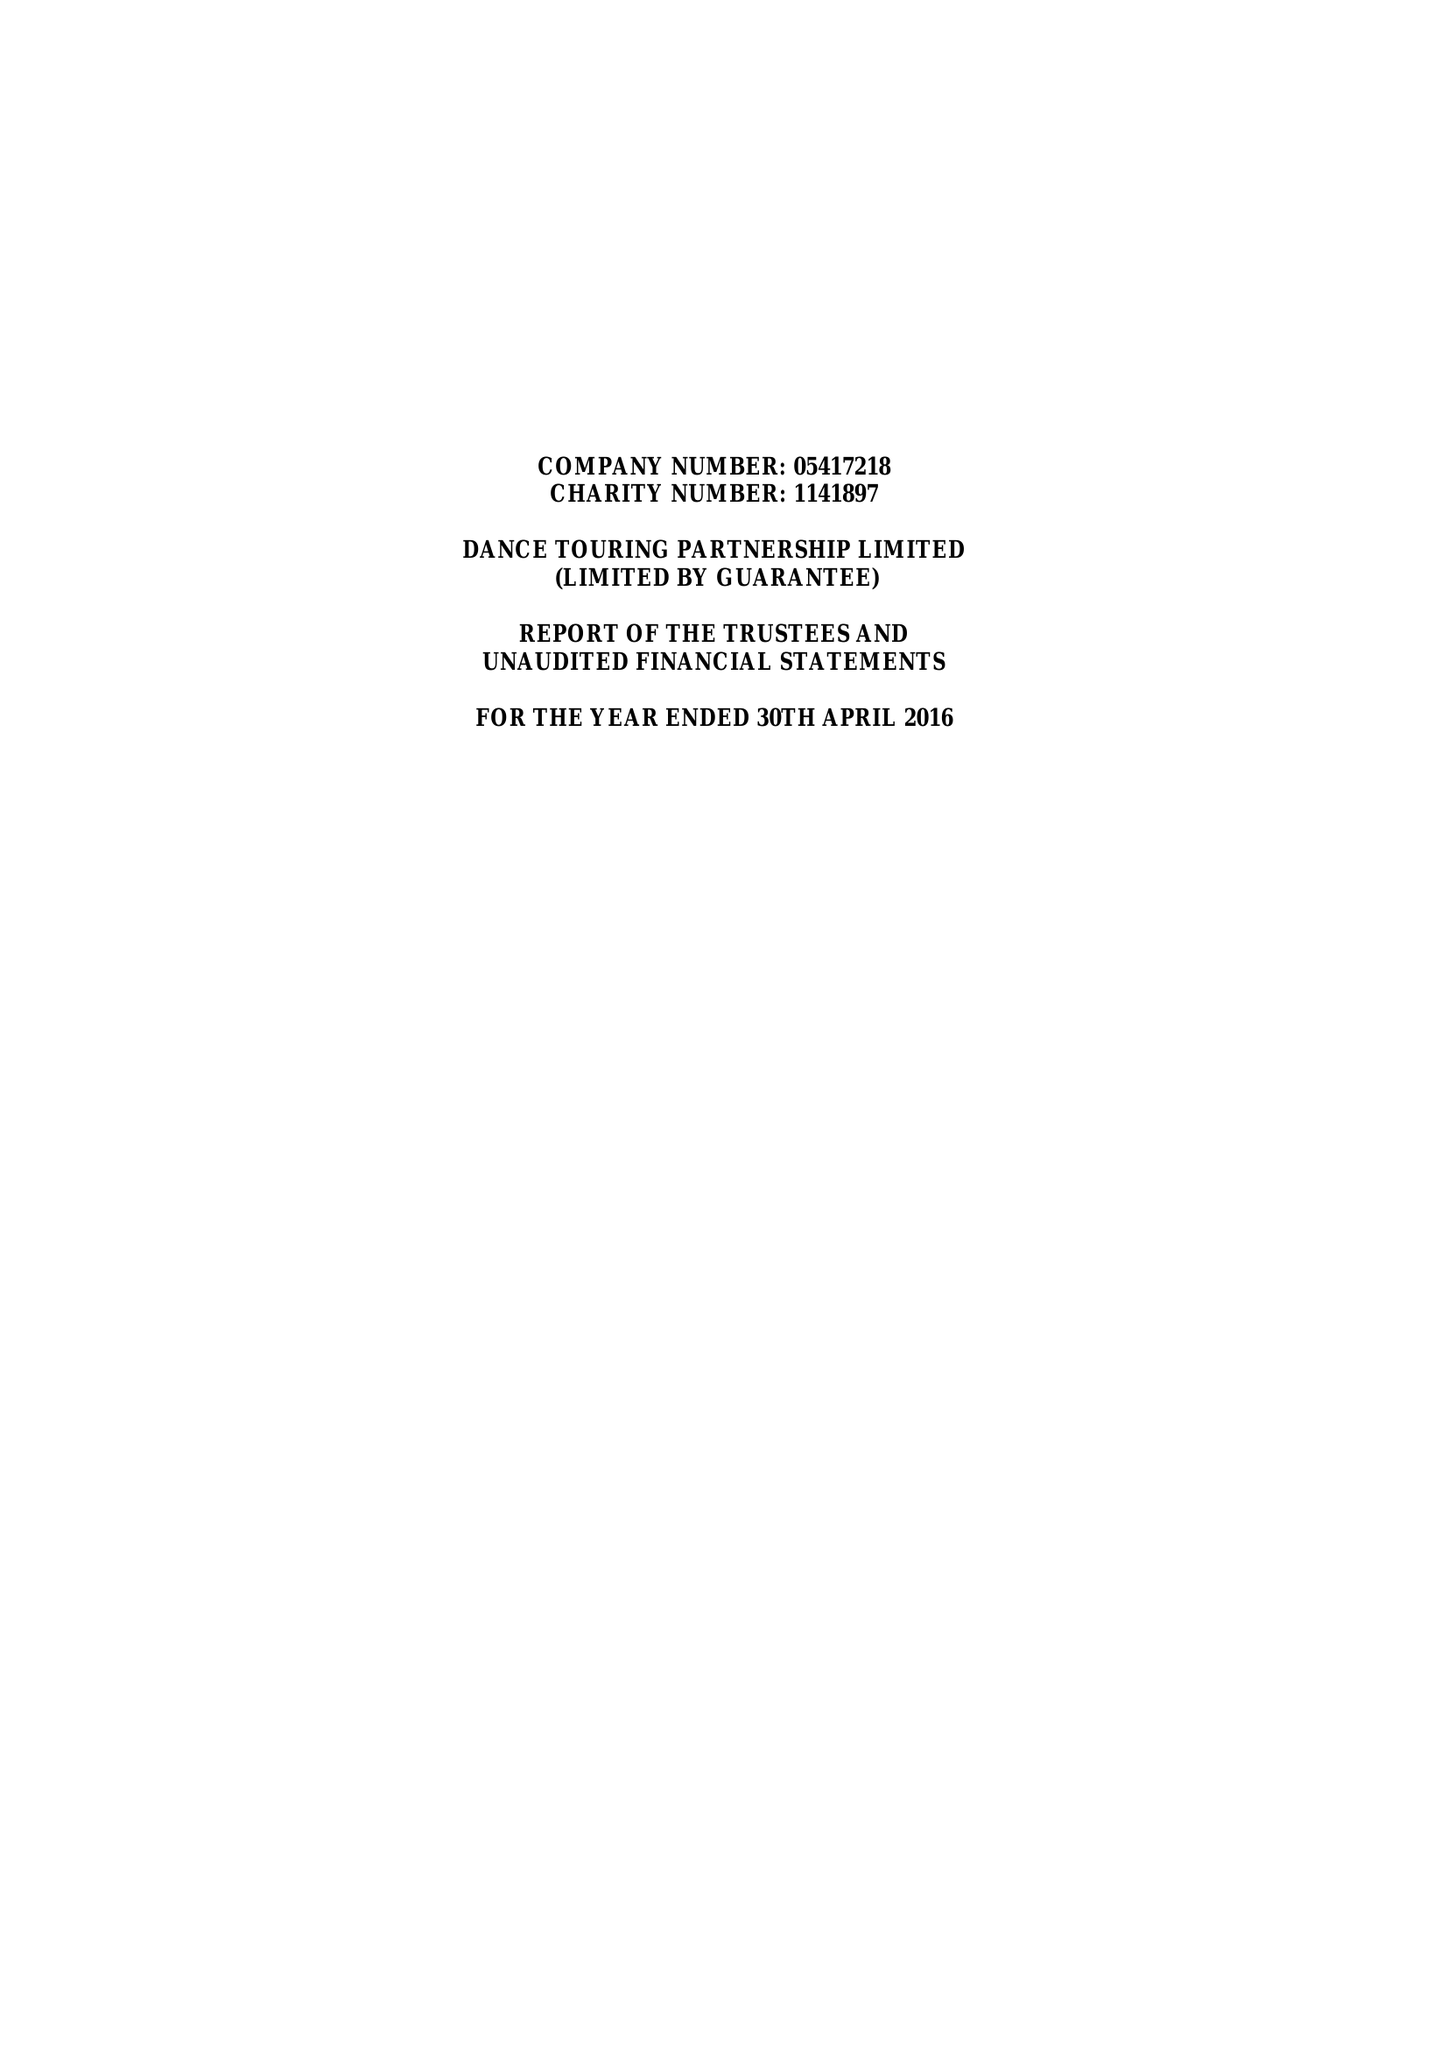What is the value for the report_date?
Answer the question using a single word or phrase. 2016-04-30 